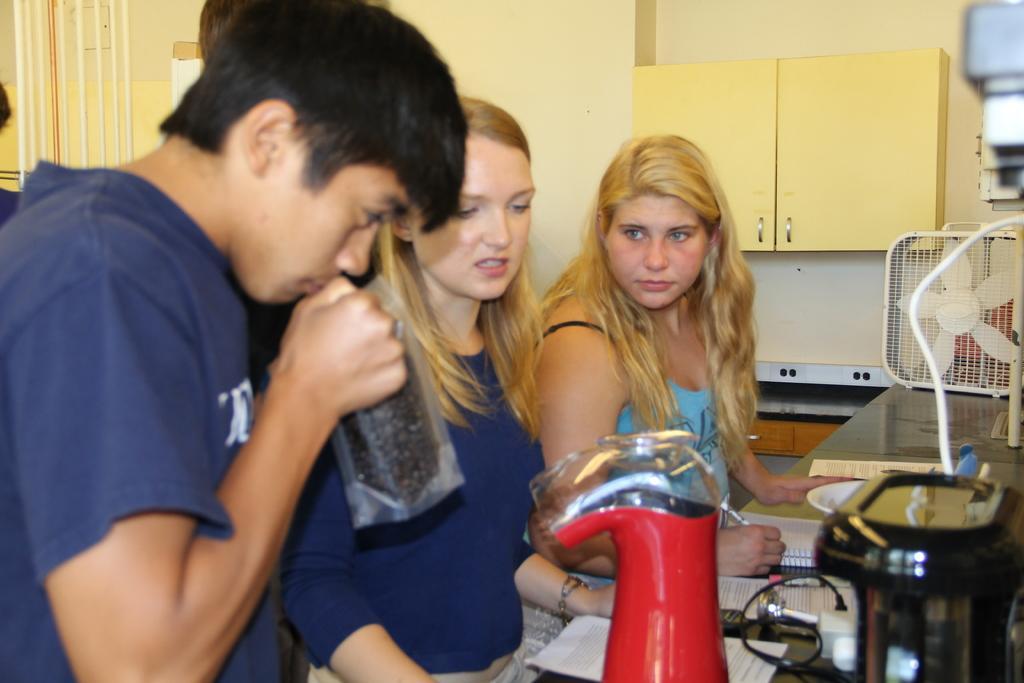Please provide a concise description of this image. In this image we can see people standing. In front of them there is a platform on which there are objects. In the background of the image there is wall. There is a cupboard. 